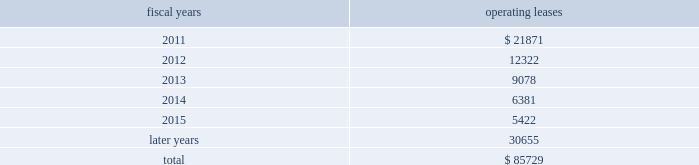The following is a schedule of future minimum rental payments required under long-term operating leases at october 30 , 2010 : fiscal years operating leases .
12 .
Commitments and contingencies from time to time in the ordinary course of the company 2019s business , various claims , charges and litigation are asserted or commenced against the company arising from , or related to , contractual matters , patents , trademarks , personal injury , environmental matters , product liability , insurance coverage and personnel and employment disputes .
As to such claims and litigation , the company can give no assurance that it will prevail .
The company does not believe that any current legal matters will have a material adverse effect on the company 2019s financial position , results of operations or cash flows .
13 .
Retirement plans the company and its subsidiaries have various savings and retirement plans covering substantially all employees .
The company maintains a defined contribution plan for the benefit of its eligible u.s .
Employees .
This plan provides for company contributions of up to 5% ( 5 % ) of each participant 2019s total eligible compensation .
In addition , the company contributes an amount equal to each participant 2019s pre-tax contribution , if any , up to a maximum of 3% ( 3 % ) of each participant 2019s total eligible compensation .
The total expense related to the defined contribution plan for u.s .
Employees was $ 20.5 million in fiscal 2010 , $ 21.5 million in fiscal 2009 and $ 22.6 million in fiscal 2008 .
The company also has various defined benefit pension and other retirement plans for certain non-u.s .
Employees that are consistent with local statutory requirements and practices .
The total expense related to the various defined benefit pension and other retirement plans for certain non-u.s .
Employees was $ 11.7 million in fiscal 2010 , $ 10.9 million in fiscal 2009 and $ 13.9 million in fiscal 2008 .
During fiscal 2009 , the measurement date of the plan 2019s funded status was changed from september 30 to the company 2019s fiscal year end .
Non-u.s .
Plan disclosures the company 2019s funding policy for its foreign defined benefit pension plans is consistent with the local requirements of each country .
The plans 2019 assets consist primarily of u.s .
And non-u.s .
Equity securities , bonds , property and cash .
The benefit obligations and related assets under these plans have been measured at october 30 , 2010 and october 31 , 2009 .
Analog devices , inc .
Notes to consolidated financial statements 2014 ( continued ) .
What is the percentage change in the total expense related to the defined contribution plan for non-u.s employees in 2010? 
Computations: ((11.7 - 10.9) / 10.9)
Answer: 0.07339. 